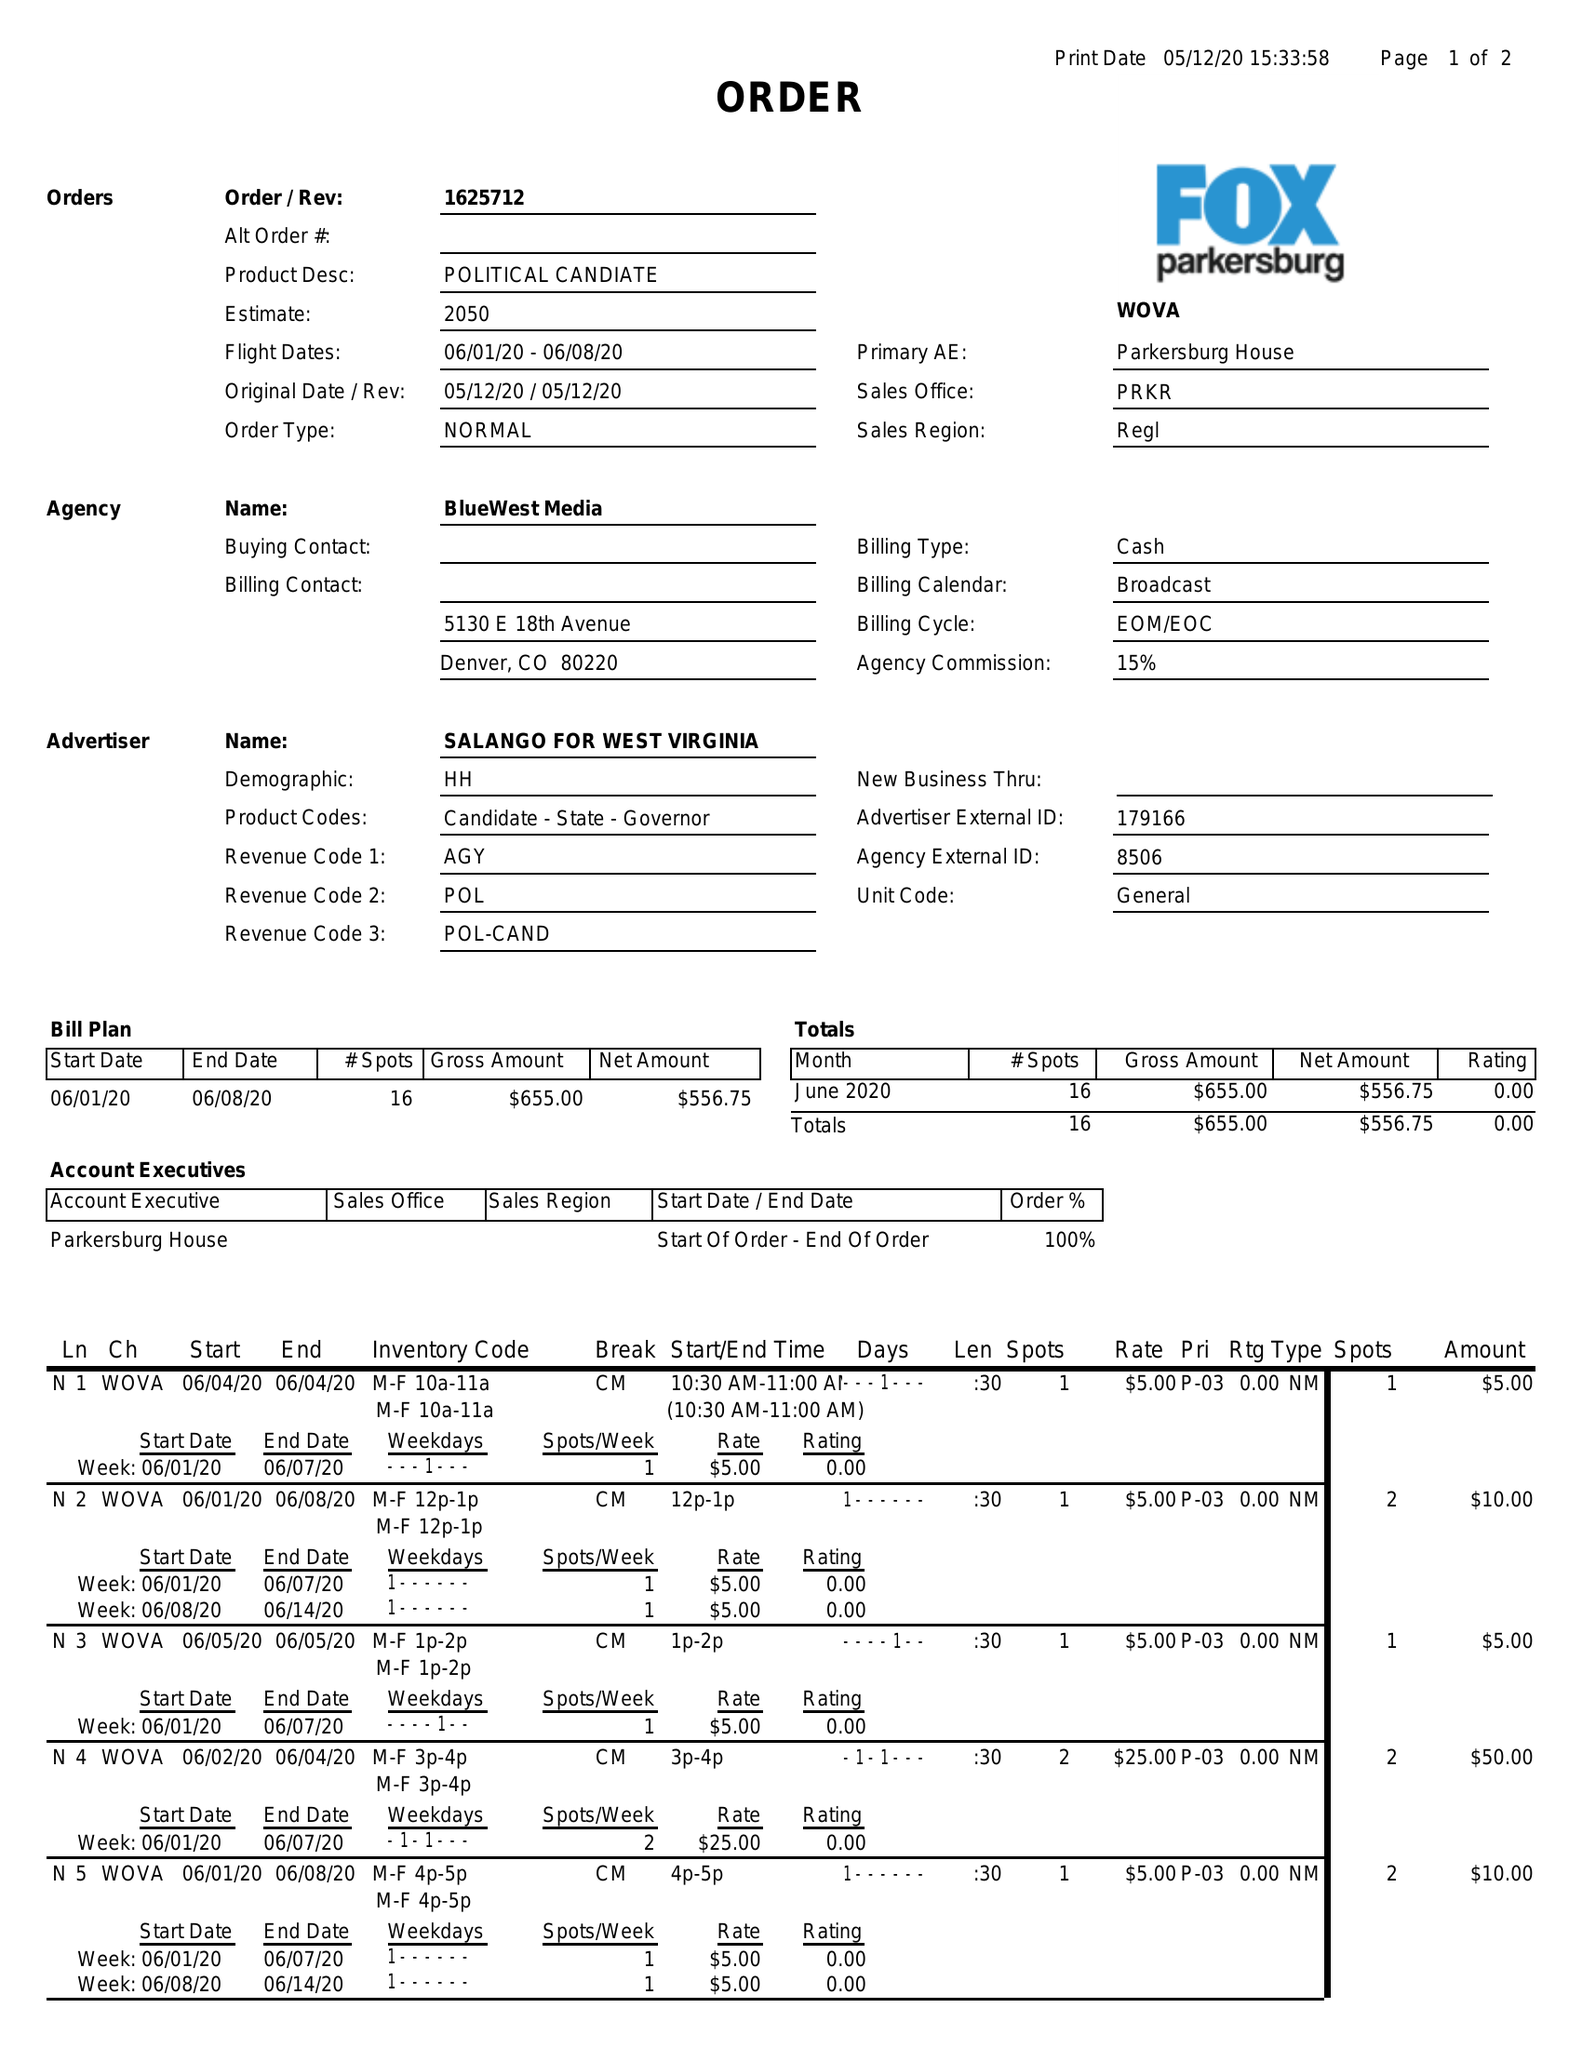What is the value for the flight_to?
Answer the question using a single word or phrase. 06/08/20 